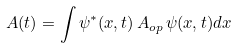<formula> <loc_0><loc_0><loc_500><loc_500>A ( t ) = \int \psi ^ { * } ( x , t ) \, A _ { o p } \, \psi ( x , t ) d x</formula> 